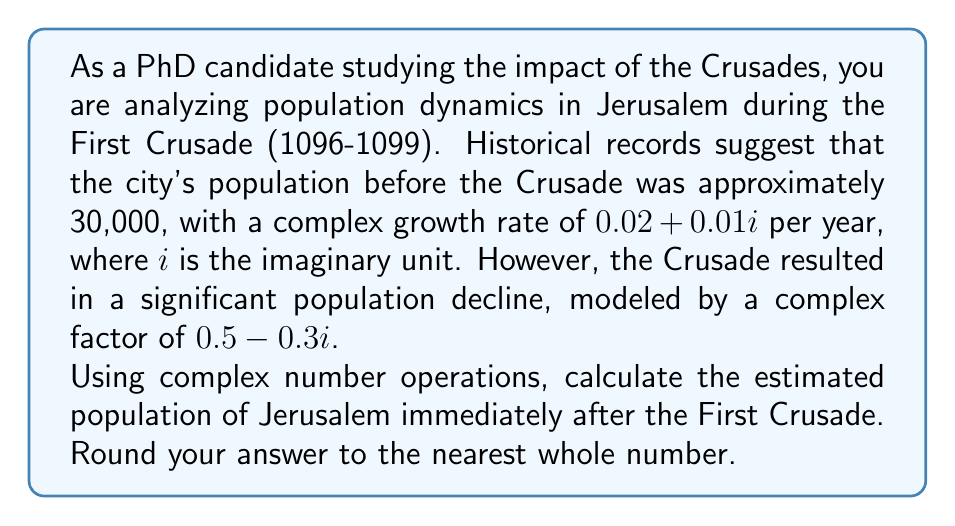Show me your answer to this math problem. To solve this problem, we'll use complex number operations to model the population changes:

1. Initial population: $P_0 = 30,000$

2. Growth rate: $r = 0.02 + 0.01i$ per year

3. Time period: $t = 3$ years (1096-1099)

4. Crusade impact factor: $f = 0.5 - 0.3i$

Step 1: Calculate the population growth without the Crusade impact
$$P_1 = P_0 \cdot (1 + r)^t$$
$$P_1 = 30,000 \cdot (1 + 0.02 + 0.01i)^3$$

Using De Moivre's formula for complex exponentiation:
$$(a + bi)^n = r^n(\cos(n\theta) + i\sin(n\theta))$$
Where $r = \sqrt{a^2 + b^2}$ and $\theta = \arctan(\frac{b}{a})$

Here, $r = \sqrt{1.02^2 + 0.01^2} \approx 1.0201$ and $\theta = \arctan(\frac{0.01}{1.02}) \approx 0.0098$

$$P_1 = 30,000 \cdot 1.0201^3 \cdot (\cos(3 \cdot 0.0098) + i\sin(3 \cdot 0.0098))$$
$$P_1 \approx 30,000 \cdot 1.0612 \cdot (0.9999 + 0.0294i)$$
$$P_1 \approx 31,836 + 937i$$

Step 2: Apply the Crusade impact factor
$$P_2 = P_1 \cdot f$$
$$P_2 = (31,836 + 937i) \cdot (0.5 - 0.3i)$$

Multiplying complex numbers: $(a+bi)(c+di) = (ac-bd) + (ad+bc)i$

$$P_2 = (31,836 \cdot 0.5 - 937 \cdot (-0.3)) + (31,836 \cdot (-0.3) + 937 \cdot 0.5)i$$
$$P_2 = 16,199.1 - 9,269.7i$$

Step 3: Calculate the magnitude of the complex population
$$|P_2| = \sqrt{16,199.1^2 + (-9,269.7)^2} \approx 18,674.8$$

Rounding to the nearest whole number: 18,675
Answer: 18,675 